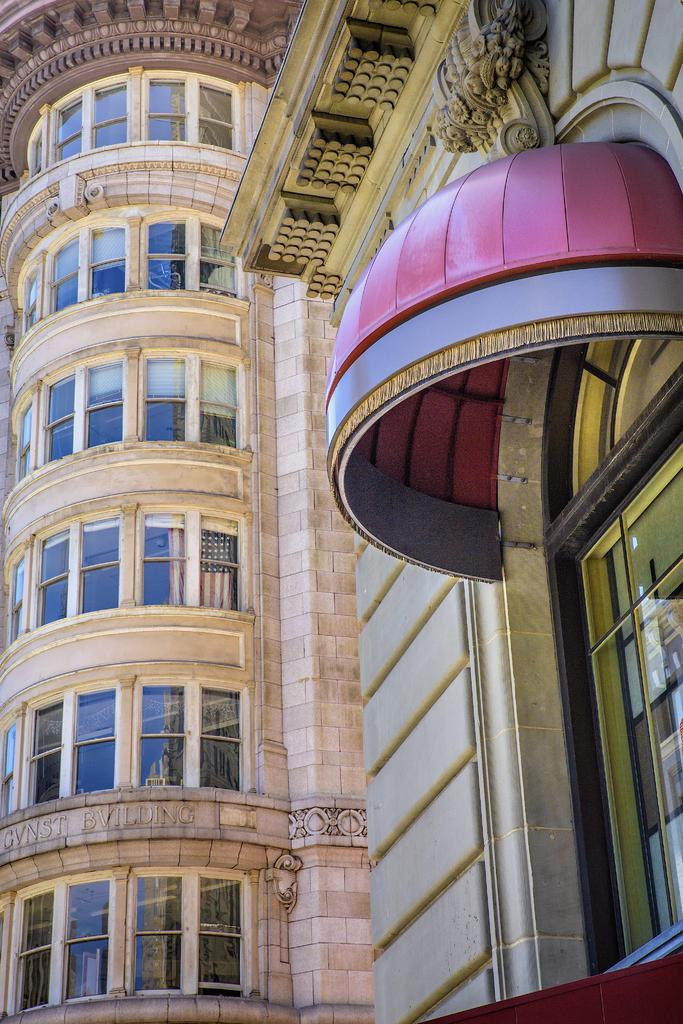What type of structure is visible in the image? There is a building in the image. What are some features of the building? The building has windows and a roof. What type of bead is used to decorate the roof of the building in the image? There is no bead present on the roof of the building in the image. Can you hear the voice of the architect who designed the building in the image? The image is a still photograph and does not contain any sound, so it is not possible to hear the voice of the architect who designed the building. 